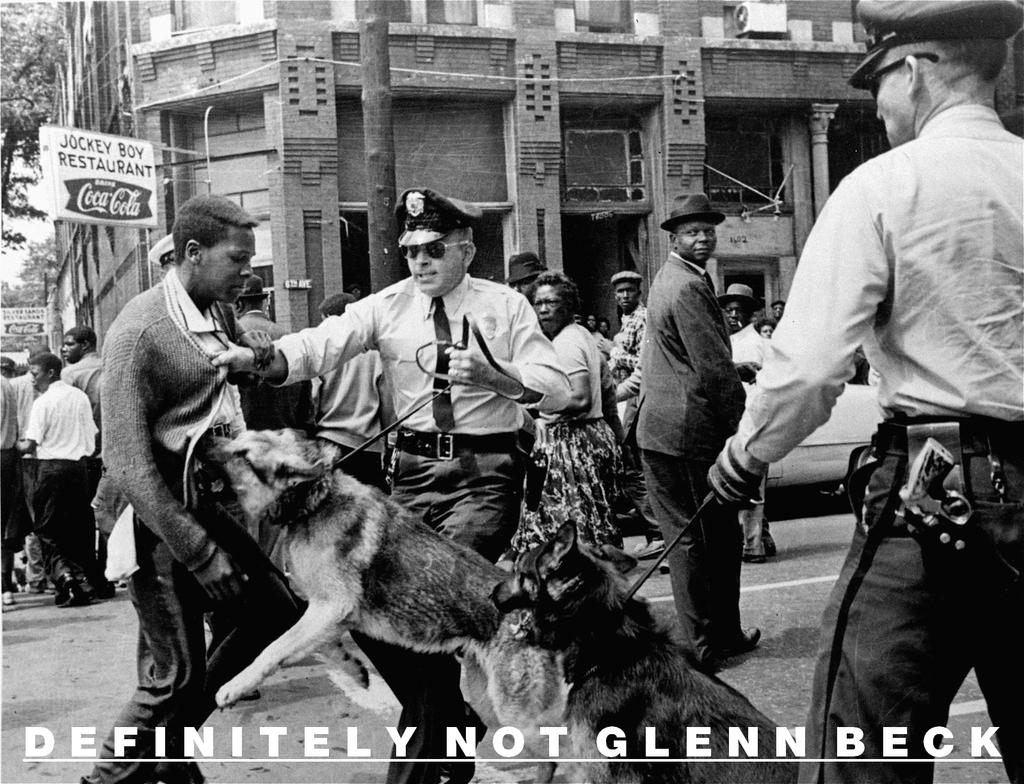How many people are in the image? There are two persons in the image. What are the persons wearing? Both persons are wearing caps and goggles. What are the persons holding in the image? The persons are holding dogs with a belt. Can you describe the background of the image? There is a tree, a building, and a name board in the background of the image. What type of payment is being made in the image? There is no indication of any payment being made in the image. What is the attention of the persons in the image focused on? The image does not provide information about the attention of the persons; they are simply holding dogs with a belt. 